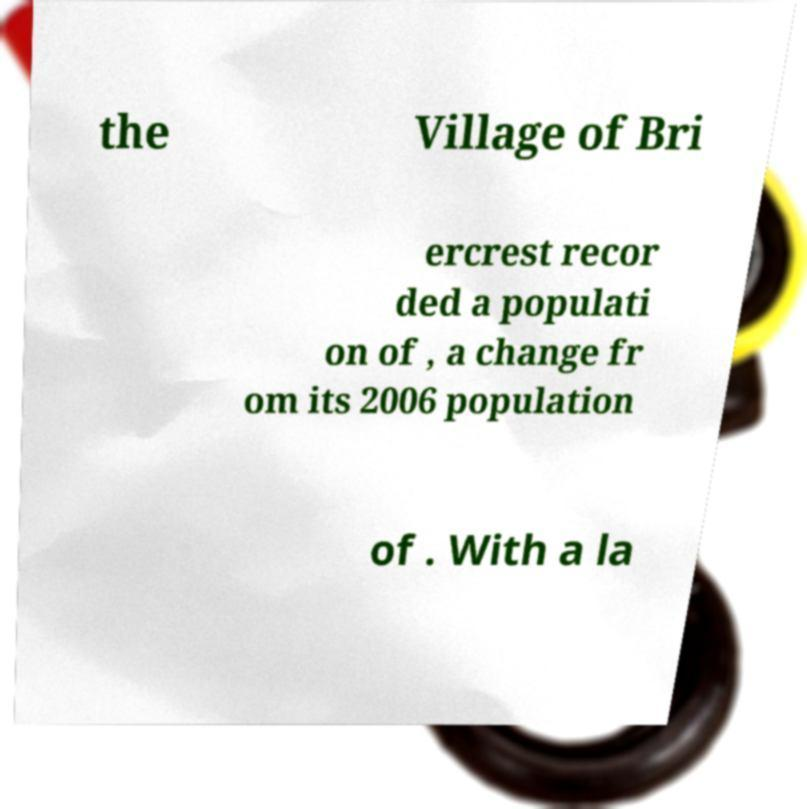Can you read and provide the text displayed in the image?This photo seems to have some interesting text. Can you extract and type it out for me? the Village of Bri ercrest recor ded a populati on of , a change fr om its 2006 population of . With a la 